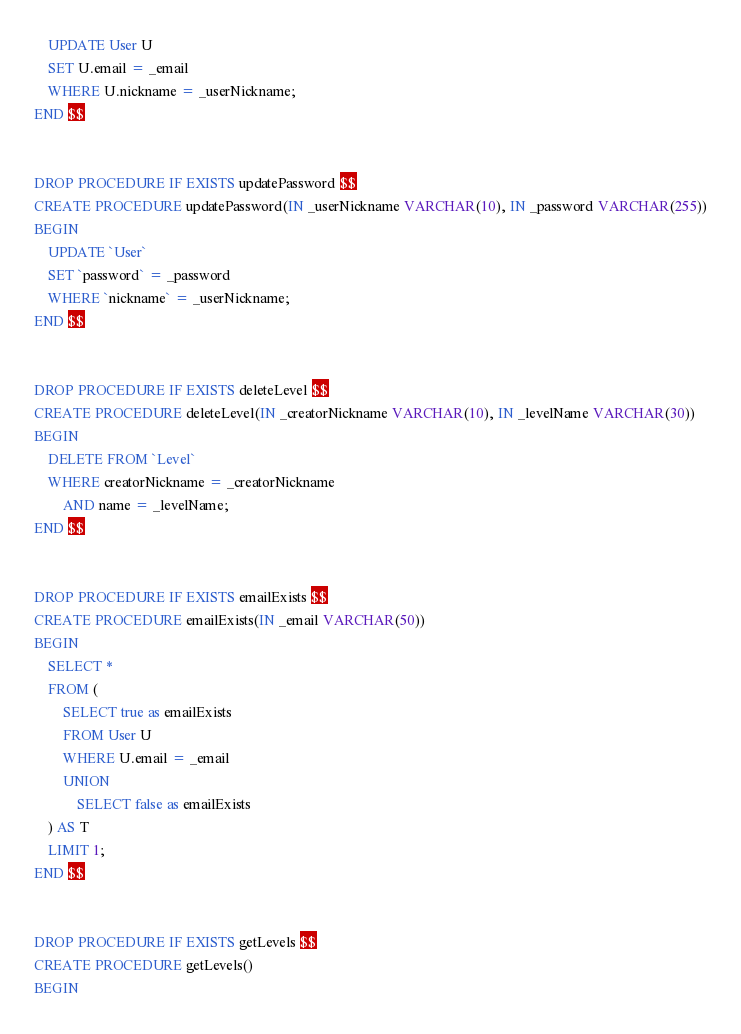<code> <loc_0><loc_0><loc_500><loc_500><_SQL_>    UPDATE User U
    SET U.email = _email
    WHERE U.nickname = _userNickname;
END $$


DROP PROCEDURE IF EXISTS updatePassword $$
CREATE PROCEDURE updatePassword(IN _userNickname VARCHAR(10), IN _password VARCHAR(255))
BEGIN
    UPDATE `User`
    SET `password` = _password
    WHERE `nickname` = _userNickname;
END $$


DROP PROCEDURE IF EXISTS deleteLevel $$
CREATE PROCEDURE deleteLevel(IN _creatorNickname VARCHAR(10), IN _levelName VARCHAR(30))
BEGIN
	DELETE FROM `Level`
    WHERE creatorNickname = _creatorNickname
		AND name = _levelName;
END $$


DROP PROCEDURE IF EXISTS emailExists $$
CREATE PROCEDURE emailExists(IN _email VARCHAR(50))
BEGIN
    SELECT *
    FROM (
        SELECT true as emailExists
        FROM User U
        WHERE U.email = _email
        UNION
            SELECT false as emailExists
    ) AS T
    LIMIT 1;
END $$


DROP PROCEDURE IF EXISTS getLevels $$
CREATE PROCEDURE getLevels()
BEGIN</code> 